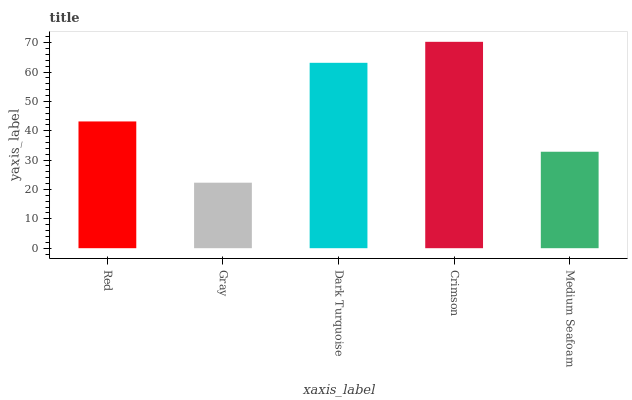Is Gray the minimum?
Answer yes or no. Yes. Is Crimson the maximum?
Answer yes or no. Yes. Is Dark Turquoise the minimum?
Answer yes or no. No. Is Dark Turquoise the maximum?
Answer yes or no. No. Is Dark Turquoise greater than Gray?
Answer yes or no. Yes. Is Gray less than Dark Turquoise?
Answer yes or no. Yes. Is Gray greater than Dark Turquoise?
Answer yes or no. No. Is Dark Turquoise less than Gray?
Answer yes or no. No. Is Red the high median?
Answer yes or no. Yes. Is Red the low median?
Answer yes or no. Yes. Is Crimson the high median?
Answer yes or no. No. Is Dark Turquoise the low median?
Answer yes or no. No. 